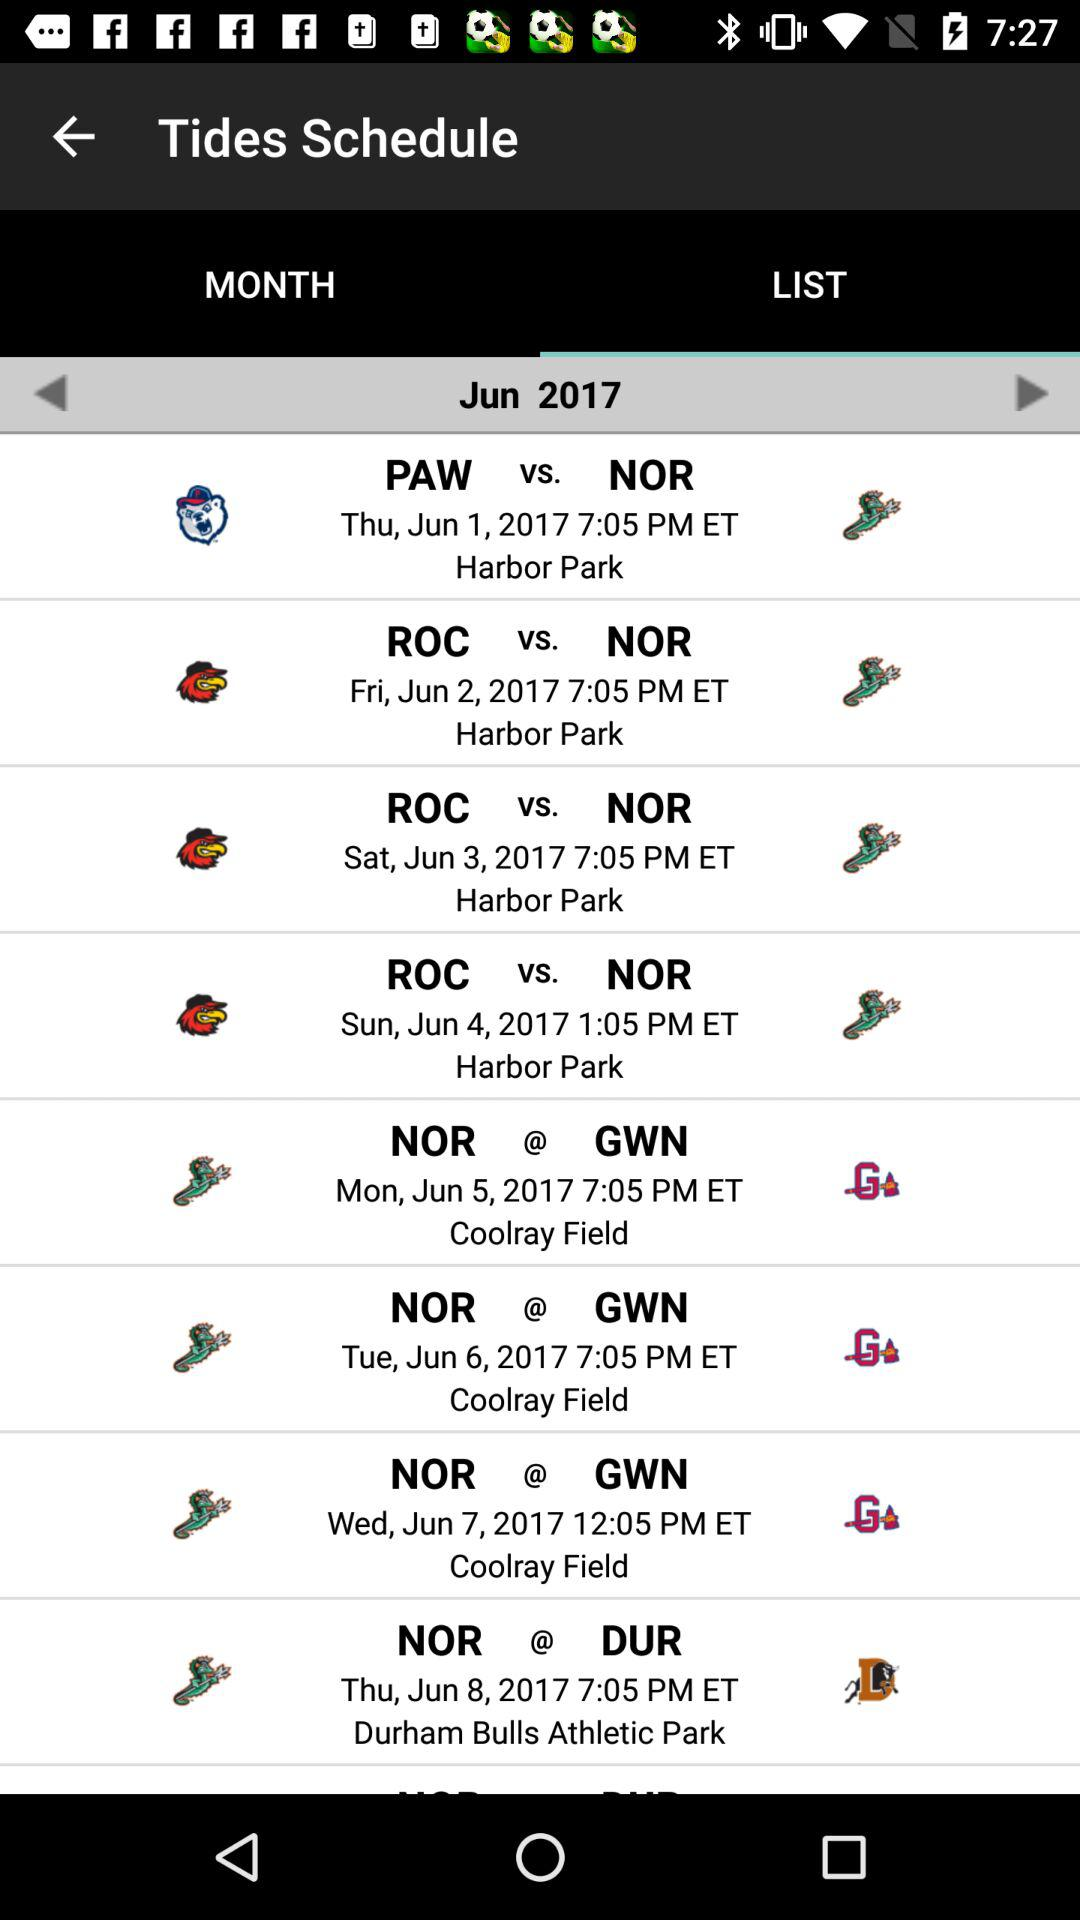The list is given for what month? The list is given for the June month. 